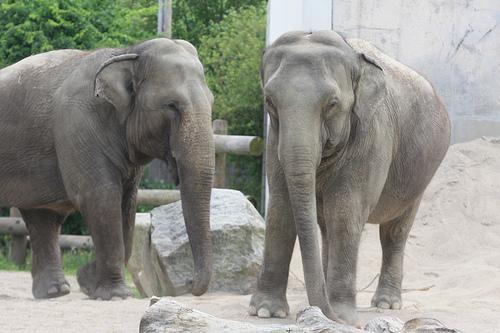Question: where is the picture taken?
Choices:
A. Maze.
B. Haunted house.
C. At an elephant exhibit.
D. Skateboard park.
Answer with the letter. Answer: C Question: what animal is seen?
Choices:
A. Giraffe.
B. Goat.
C. Dog.
D. Elephant.
Answer with the letter. Answer: D Question: how many elephants?
Choices:
A. 3.
B. 2.
C. 4.
D. 5.
Answer with the letter. Answer: B Question: what are the elephant doing?
Choices:
A. Eating.
B. Drinking.
C. Walking.
D. Bathing.
Answer with the letter. Answer: C Question: what is the color of the elephant?
Choices:
A. Brown.
B. Beige.
C. Grey.
D. Black.
Answer with the letter. Answer: C Question: what is the color of the leaves?
Choices:
A. Yellow.
B. Green.
C. Red.
D. Orange.
Answer with the letter. Answer: B 